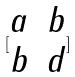<formula> <loc_0><loc_0><loc_500><loc_500>[ \begin{matrix} a & b \\ b & d \end{matrix} ]</formula> 